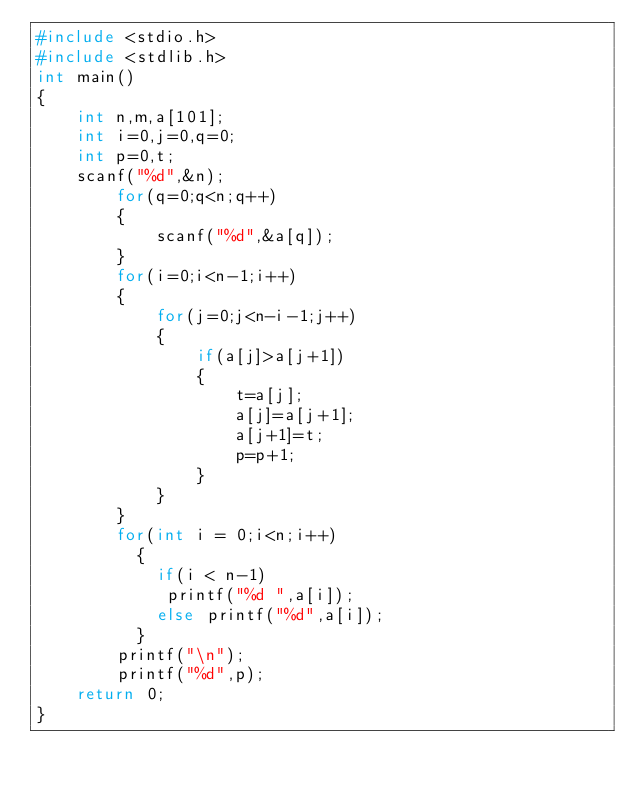<code> <loc_0><loc_0><loc_500><loc_500><_C_>#include <stdio.h>
#include <stdlib.h>
int main()
{
    int n,m,a[101];
    int i=0,j=0,q=0;
    int p=0,t;
    scanf("%d",&n);
        for(q=0;q<n;q++)
        {
            scanf("%d",&a[q]);
        }
        for(i=0;i<n-1;i++)
        {
            for(j=0;j<n-i-1;j++)
            {
                if(a[j]>a[j+1])
                {
                    t=a[j];
                    a[j]=a[j+1];
                    a[j+1]=t;
                    p=p+1;
                }
            }
        }
        for(int i = 0;i<n;i++)
          {
            if(i < n-1)
             printf("%d ",a[i]);
            else printf("%d",a[i]);
          }
        printf("\n");
        printf("%d",p);
    return 0;
}

</code> 